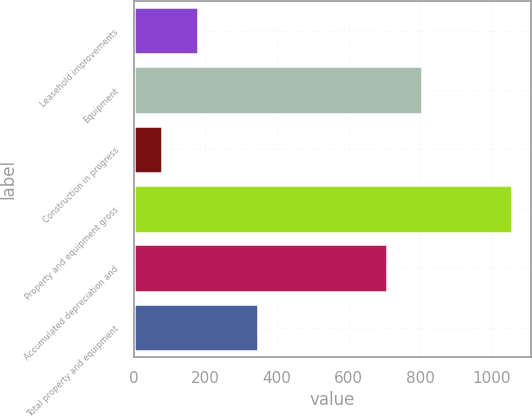Convert chart to OTSL. <chart><loc_0><loc_0><loc_500><loc_500><bar_chart><fcel>Leasehold improvements<fcel>Equipment<fcel>Construction in progress<fcel>Property and equipment gross<fcel>Accumulated depreciation and<fcel>Total property and equipment<nl><fcel>179<fcel>804.7<fcel>78<fcel>1055<fcel>707<fcel>348<nl></chart> 